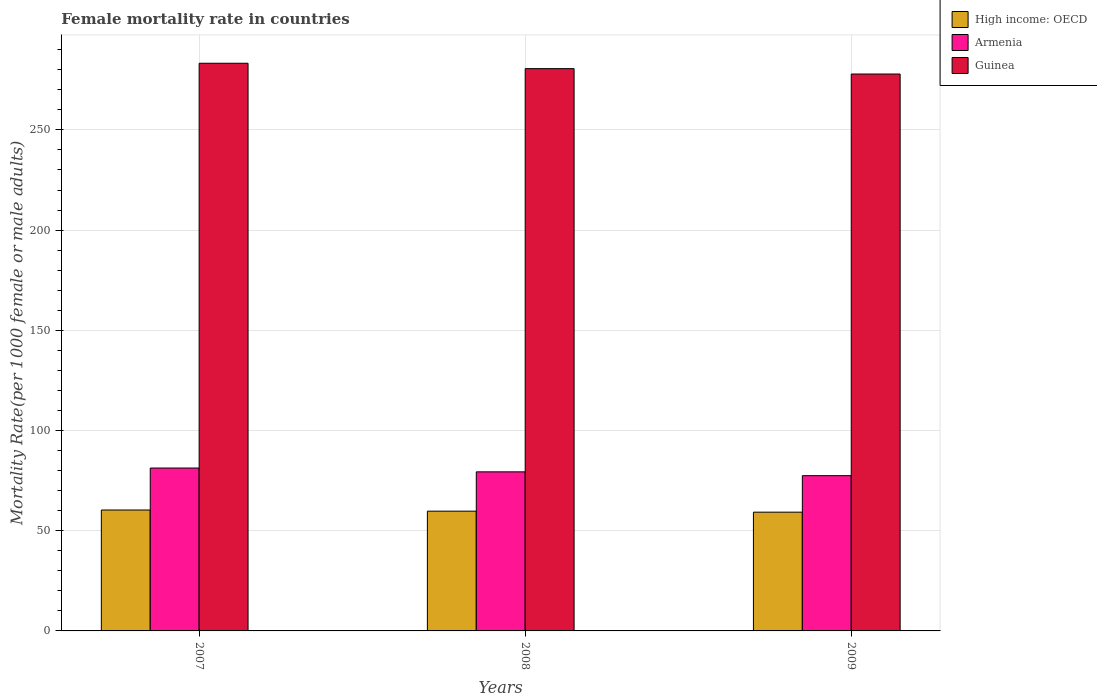Are the number of bars on each tick of the X-axis equal?
Ensure brevity in your answer.  Yes. What is the female mortality rate in Guinea in 2009?
Keep it short and to the point. 277.89. Across all years, what is the maximum female mortality rate in Guinea?
Ensure brevity in your answer.  283.25. Across all years, what is the minimum female mortality rate in Armenia?
Offer a very short reply. 77.47. In which year was the female mortality rate in Armenia maximum?
Your answer should be compact. 2007. In which year was the female mortality rate in High income: OECD minimum?
Provide a succinct answer. 2009. What is the total female mortality rate in High income: OECD in the graph?
Offer a terse response. 179.36. What is the difference between the female mortality rate in Armenia in 2007 and that in 2008?
Keep it short and to the point. 1.91. What is the difference between the female mortality rate in Armenia in 2007 and the female mortality rate in High income: OECD in 2009?
Your answer should be compact. 22.02. What is the average female mortality rate in Guinea per year?
Provide a short and direct response. 280.57. In the year 2008, what is the difference between the female mortality rate in High income: OECD and female mortality rate in Armenia?
Make the answer very short. -19.62. In how many years, is the female mortality rate in Guinea greater than 50?
Your answer should be very brief. 3. What is the ratio of the female mortality rate in High income: OECD in 2007 to that in 2008?
Ensure brevity in your answer.  1.01. Is the difference between the female mortality rate in High income: OECD in 2007 and 2008 greater than the difference between the female mortality rate in Armenia in 2007 and 2008?
Keep it short and to the point. No. What is the difference between the highest and the second highest female mortality rate in Guinea?
Your answer should be compact. 2.69. What is the difference between the highest and the lowest female mortality rate in High income: OECD?
Your response must be concise. 1.08. Is the sum of the female mortality rate in High income: OECD in 2007 and 2008 greater than the maximum female mortality rate in Armenia across all years?
Provide a short and direct response. Yes. What does the 2nd bar from the left in 2008 represents?
Ensure brevity in your answer.  Armenia. What does the 2nd bar from the right in 2008 represents?
Your response must be concise. Armenia. Is it the case that in every year, the sum of the female mortality rate in High income: OECD and female mortality rate in Guinea is greater than the female mortality rate in Armenia?
Your answer should be very brief. Yes. Are all the bars in the graph horizontal?
Your answer should be compact. No. What is the difference between two consecutive major ticks on the Y-axis?
Ensure brevity in your answer.  50. Does the graph contain any zero values?
Your response must be concise. No. Where does the legend appear in the graph?
Keep it short and to the point. Top right. How are the legend labels stacked?
Your answer should be compact. Vertical. What is the title of the graph?
Keep it short and to the point. Female mortality rate in countries. Does "Denmark" appear as one of the legend labels in the graph?
Provide a succinct answer. No. What is the label or title of the X-axis?
Keep it short and to the point. Years. What is the label or title of the Y-axis?
Ensure brevity in your answer.  Mortality Rate(per 1000 female or male adults). What is the Mortality Rate(per 1000 female or male adults) in High income: OECD in 2007?
Provide a short and direct response. 60.34. What is the Mortality Rate(per 1000 female or male adults) of Armenia in 2007?
Provide a short and direct response. 81.28. What is the Mortality Rate(per 1000 female or male adults) in Guinea in 2007?
Make the answer very short. 283.25. What is the Mortality Rate(per 1000 female or male adults) of High income: OECD in 2008?
Your answer should be very brief. 59.76. What is the Mortality Rate(per 1000 female or male adults) of Armenia in 2008?
Offer a very short reply. 79.37. What is the Mortality Rate(per 1000 female or male adults) of Guinea in 2008?
Your response must be concise. 280.57. What is the Mortality Rate(per 1000 female or male adults) in High income: OECD in 2009?
Give a very brief answer. 59.26. What is the Mortality Rate(per 1000 female or male adults) of Armenia in 2009?
Offer a terse response. 77.47. What is the Mortality Rate(per 1000 female or male adults) in Guinea in 2009?
Offer a terse response. 277.89. Across all years, what is the maximum Mortality Rate(per 1000 female or male adults) in High income: OECD?
Keep it short and to the point. 60.34. Across all years, what is the maximum Mortality Rate(per 1000 female or male adults) in Armenia?
Keep it short and to the point. 81.28. Across all years, what is the maximum Mortality Rate(per 1000 female or male adults) of Guinea?
Provide a succinct answer. 283.25. Across all years, what is the minimum Mortality Rate(per 1000 female or male adults) in High income: OECD?
Keep it short and to the point. 59.26. Across all years, what is the minimum Mortality Rate(per 1000 female or male adults) of Armenia?
Your response must be concise. 77.47. Across all years, what is the minimum Mortality Rate(per 1000 female or male adults) of Guinea?
Offer a very short reply. 277.89. What is the total Mortality Rate(per 1000 female or male adults) in High income: OECD in the graph?
Provide a short and direct response. 179.36. What is the total Mortality Rate(per 1000 female or male adults) of Armenia in the graph?
Make the answer very short. 238.12. What is the total Mortality Rate(per 1000 female or male adults) in Guinea in the graph?
Offer a very short reply. 841.71. What is the difference between the Mortality Rate(per 1000 female or male adults) of High income: OECD in 2007 and that in 2008?
Provide a succinct answer. 0.58. What is the difference between the Mortality Rate(per 1000 female or male adults) in Armenia in 2007 and that in 2008?
Provide a short and direct response. 1.91. What is the difference between the Mortality Rate(per 1000 female or male adults) in Guinea in 2007 and that in 2008?
Make the answer very short. 2.69. What is the difference between the Mortality Rate(per 1000 female or male adults) in High income: OECD in 2007 and that in 2009?
Ensure brevity in your answer.  1.08. What is the difference between the Mortality Rate(per 1000 female or male adults) of Armenia in 2007 and that in 2009?
Your response must be concise. 3.81. What is the difference between the Mortality Rate(per 1000 female or male adults) of Guinea in 2007 and that in 2009?
Make the answer very short. 5.37. What is the difference between the Mortality Rate(per 1000 female or male adults) of High income: OECD in 2008 and that in 2009?
Provide a succinct answer. 0.5. What is the difference between the Mortality Rate(per 1000 female or male adults) in Armenia in 2008 and that in 2009?
Your answer should be very brief. 1.91. What is the difference between the Mortality Rate(per 1000 female or male adults) in Guinea in 2008 and that in 2009?
Your response must be concise. 2.68. What is the difference between the Mortality Rate(per 1000 female or male adults) of High income: OECD in 2007 and the Mortality Rate(per 1000 female or male adults) of Armenia in 2008?
Your answer should be very brief. -19.04. What is the difference between the Mortality Rate(per 1000 female or male adults) in High income: OECD in 2007 and the Mortality Rate(per 1000 female or male adults) in Guinea in 2008?
Your answer should be very brief. -220.23. What is the difference between the Mortality Rate(per 1000 female or male adults) in Armenia in 2007 and the Mortality Rate(per 1000 female or male adults) in Guinea in 2008?
Your response must be concise. -199.29. What is the difference between the Mortality Rate(per 1000 female or male adults) of High income: OECD in 2007 and the Mortality Rate(per 1000 female or male adults) of Armenia in 2009?
Provide a succinct answer. -17.13. What is the difference between the Mortality Rate(per 1000 female or male adults) of High income: OECD in 2007 and the Mortality Rate(per 1000 female or male adults) of Guinea in 2009?
Your response must be concise. -217.55. What is the difference between the Mortality Rate(per 1000 female or male adults) of Armenia in 2007 and the Mortality Rate(per 1000 female or male adults) of Guinea in 2009?
Keep it short and to the point. -196.61. What is the difference between the Mortality Rate(per 1000 female or male adults) in High income: OECD in 2008 and the Mortality Rate(per 1000 female or male adults) in Armenia in 2009?
Offer a terse response. -17.71. What is the difference between the Mortality Rate(per 1000 female or male adults) of High income: OECD in 2008 and the Mortality Rate(per 1000 female or male adults) of Guinea in 2009?
Keep it short and to the point. -218.13. What is the difference between the Mortality Rate(per 1000 female or male adults) in Armenia in 2008 and the Mortality Rate(per 1000 female or male adults) in Guinea in 2009?
Your answer should be compact. -198.51. What is the average Mortality Rate(per 1000 female or male adults) in High income: OECD per year?
Make the answer very short. 59.79. What is the average Mortality Rate(per 1000 female or male adults) of Armenia per year?
Your response must be concise. 79.37. What is the average Mortality Rate(per 1000 female or male adults) of Guinea per year?
Offer a very short reply. 280.57. In the year 2007, what is the difference between the Mortality Rate(per 1000 female or male adults) of High income: OECD and Mortality Rate(per 1000 female or male adults) of Armenia?
Make the answer very short. -20.94. In the year 2007, what is the difference between the Mortality Rate(per 1000 female or male adults) in High income: OECD and Mortality Rate(per 1000 female or male adults) in Guinea?
Your answer should be compact. -222.92. In the year 2007, what is the difference between the Mortality Rate(per 1000 female or male adults) of Armenia and Mortality Rate(per 1000 female or male adults) of Guinea?
Your response must be concise. -201.98. In the year 2008, what is the difference between the Mortality Rate(per 1000 female or male adults) in High income: OECD and Mortality Rate(per 1000 female or male adults) in Armenia?
Provide a succinct answer. -19.61. In the year 2008, what is the difference between the Mortality Rate(per 1000 female or male adults) of High income: OECD and Mortality Rate(per 1000 female or male adults) of Guinea?
Offer a terse response. -220.81. In the year 2008, what is the difference between the Mortality Rate(per 1000 female or male adults) in Armenia and Mortality Rate(per 1000 female or male adults) in Guinea?
Keep it short and to the point. -201.2. In the year 2009, what is the difference between the Mortality Rate(per 1000 female or male adults) in High income: OECD and Mortality Rate(per 1000 female or male adults) in Armenia?
Keep it short and to the point. -18.21. In the year 2009, what is the difference between the Mortality Rate(per 1000 female or male adults) in High income: OECD and Mortality Rate(per 1000 female or male adults) in Guinea?
Your response must be concise. -218.62. In the year 2009, what is the difference between the Mortality Rate(per 1000 female or male adults) in Armenia and Mortality Rate(per 1000 female or male adults) in Guinea?
Your response must be concise. -200.42. What is the ratio of the Mortality Rate(per 1000 female or male adults) in High income: OECD in 2007 to that in 2008?
Provide a succinct answer. 1.01. What is the ratio of the Mortality Rate(per 1000 female or male adults) of Guinea in 2007 to that in 2008?
Make the answer very short. 1.01. What is the ratio of the Mortality Rate(per 1000 female or male adults) of High income: OECD in 2007 to that in 2009?
Make the answer very short. 1.02. What is the ratio of the Mortality Rate(per 1000 female or male adults) of Armenia in 2007 to that in 2009?
Keep it short and to the point. 1.05. What is the ratio of the Mortality Rate(per 1000 female or male adults) of Guinea in 2007 to that in 2009?
Keep it short and to the point. 1.02. What is the ratio of the Mortality Rate(per 1000 female or male adults) in High income: OECD in 2008 to that in 2009?
Make the answer very short. 1.01. What is the ratio of the Mortality Rate(per 1000 female or male adults) of Armenia in 2008 to that in 2009?
Your answer should be very brief. 1.02. What is the ratio of the Mortality Rate(per 1000 female or male adults) of Guinea in 2008 to that in 2009?
Provide a succinct answer. 1.01. What is the difference between the highest and the second highest Mortality Rate(per 1000 female or male adults) of High income: OECD?
Give a very brief answer. 0.58. What is the difference between the highest and the second highest Mortality Rate(per 1000 female or male adults) in Armenia?
Make the answer very short. 1.91. What is the difference between the highest and the second highest Mortality Rate(per 1000 female or male adults) of Guinea?
Ensure brevity in your answer.  2.69. What is the difference between the highest and the lowest Mortality Rate(per 1000 female or male adults) in High income: OECD?
Your answer should be compact. 1.08. What is the difference between the highest and the lowest Mortality Rate(per 1000 female or male adults) in Armenia?
Provide a succinct answer. 3.81. What is the difference between the highest and the lowest Mortality Rate(per 1000 female or male adults) of Guinea?
Provide a short and direct response. 5.37. 